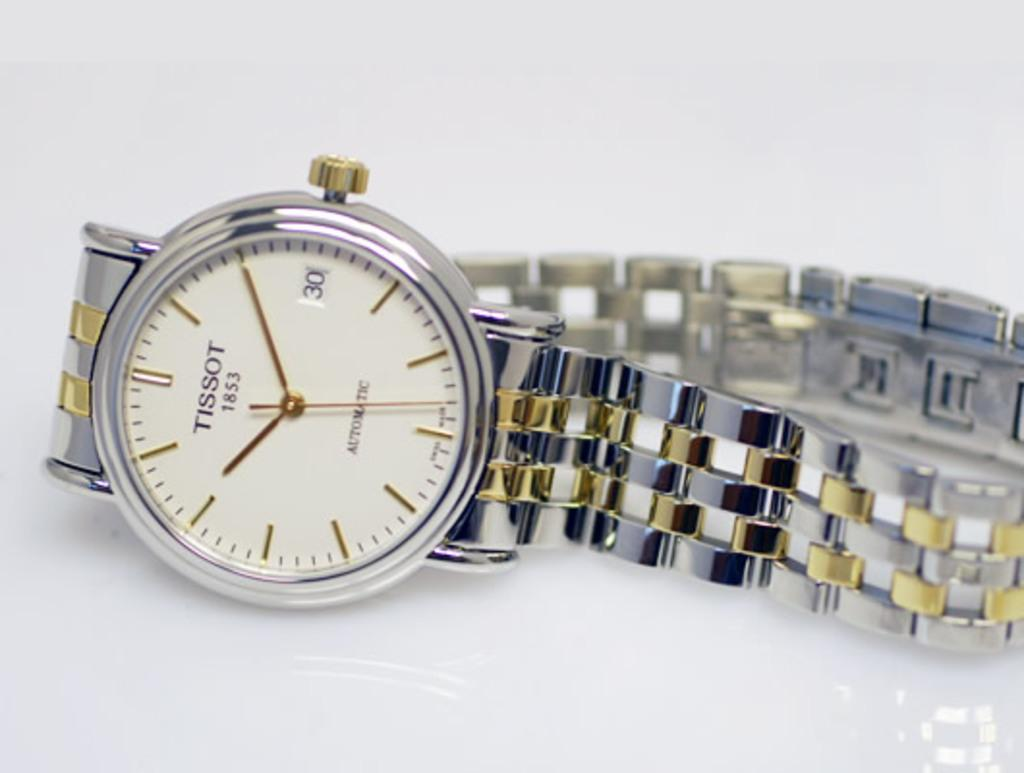<image>
Present a compact description of the photo's key features. A silver and gold watch that says Tissot 1853 